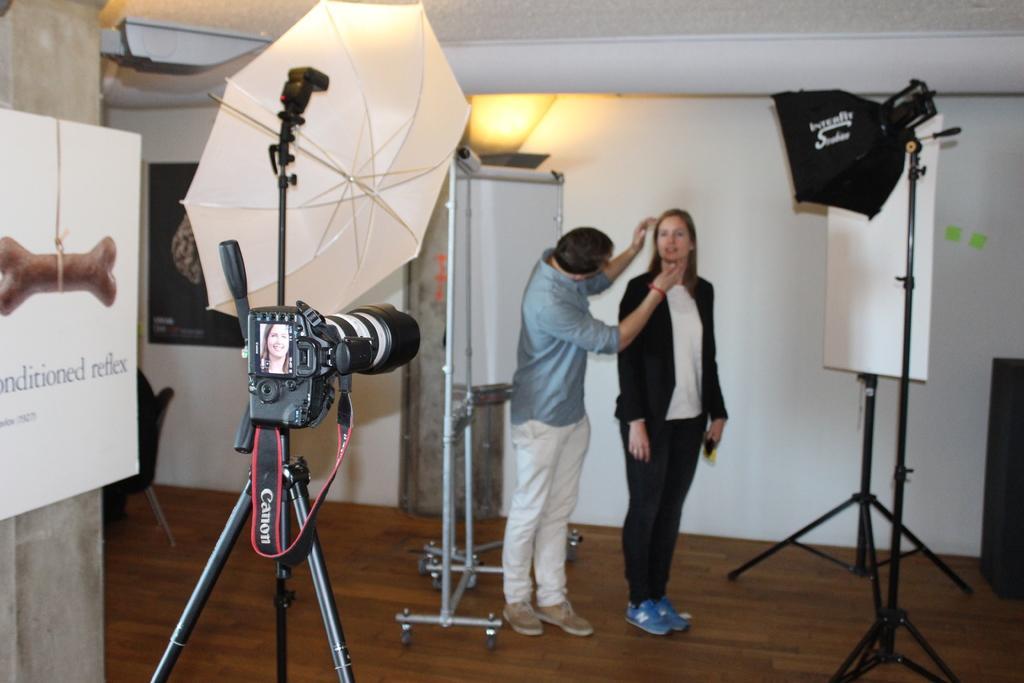Please provide a concise description of this image. This picture is clicked inside the room. On the right we can see the two persons standing on the ground and we can see the boards attached to the metal stands and we can see the umbrellas, cameras and some other items. In the left corner we can see the text and some pictures on the board. In the background we can see the wall, light and a person like thing seems to be sitting on the chair. 